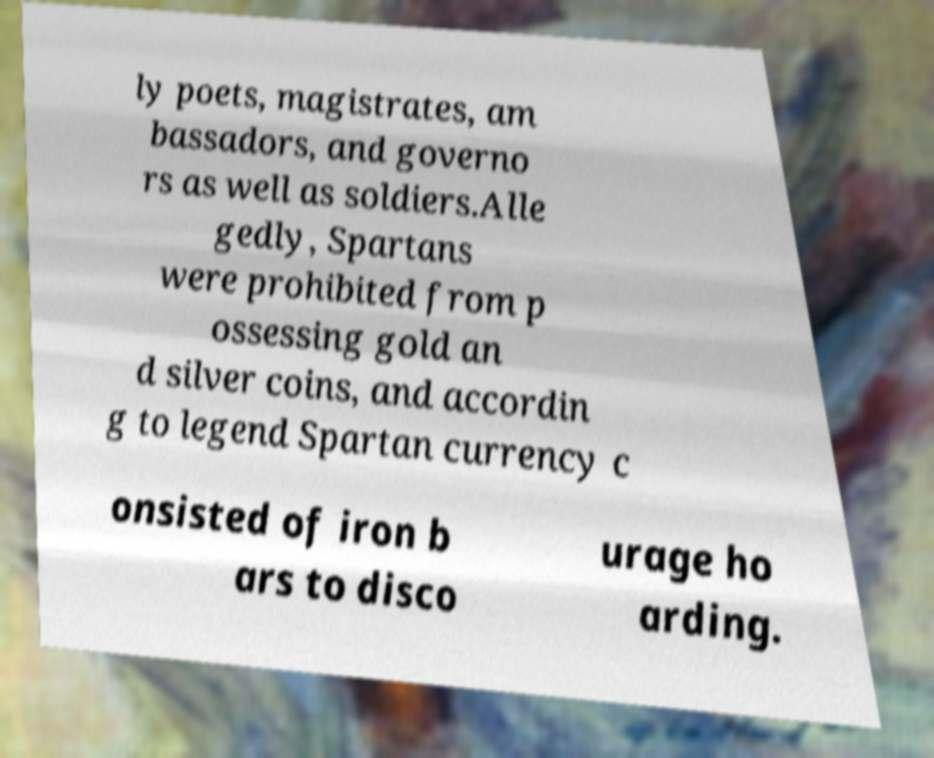What messages or text are displayed in this image? I need them in a readable, typed format. ly poets, magistrates, am bassadors, and governo rs as well as soldiers.Alle gedly, Spartans were prohibited from p ossessing gold an d silver coins, and accordin g to legend Spartan currency c onsisted of iron b ars to disco urage ho arding. 